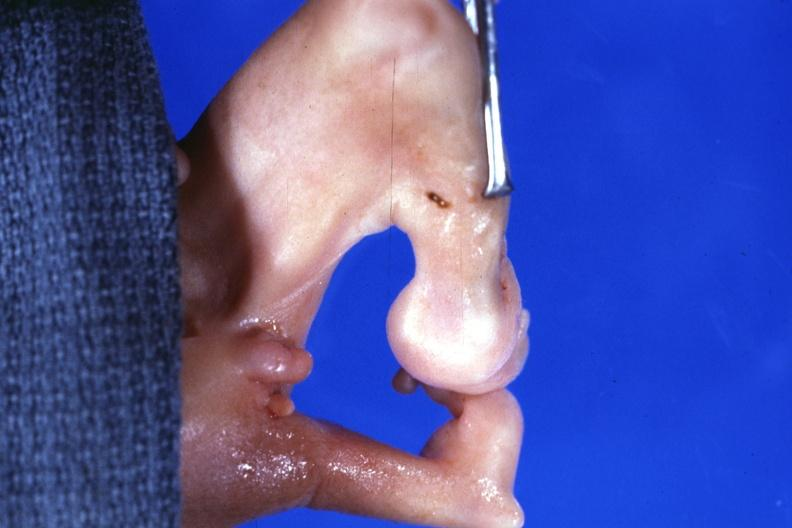does breast show marked deformity both legs?
Answer the question using a single word or phrase. No 